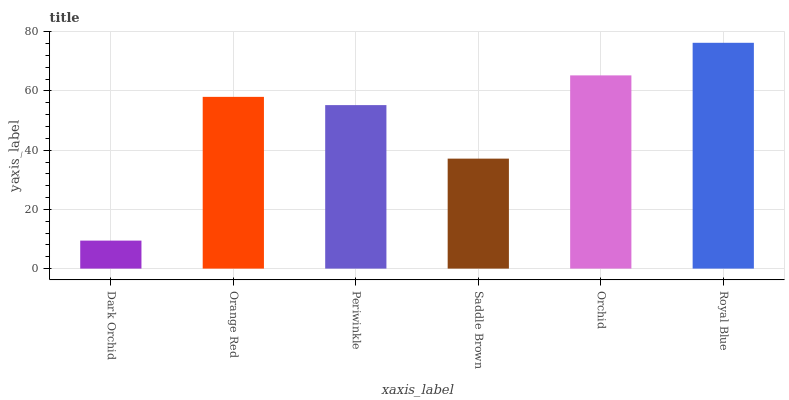Is Dark Orchid the minimum?
Answer yes or no. Yes. Is Royal Blue the maximum?
Answer yes or no. Yes. Is Orange Red the minimum?
Answer yes or no. No. Is Orange Red the maximum?
Answer yes or no. No. Is Orange Red greater than Dark Orchid?
Answer yes or no. Yes. Is Dark Orchid less than Orange Red?
Answer yes or no. Yes. Is Dark Orchid greater than Orange Red?
Answer yes or no. No. Is Orange Red less than Dark Orchid?
Answer yes or no. No. Is Orange Red the high median?
Answer yes or no. Yes. Is Periwinkle the low median?
Answer yes or no. Yes. Is Dark Orchid the high median?
Answer yes or no. No. Is Orange Red the low median?
Answer yes or no. No. 